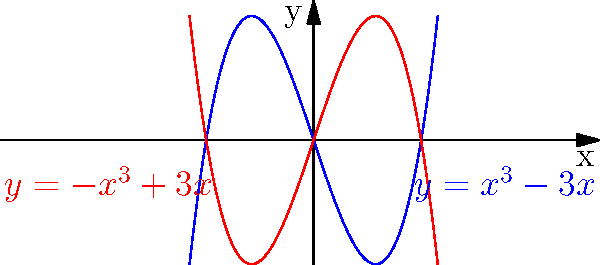As a creative mentor introducing new artistic techniques, you're demonstrating how polynomial functions can generate dynamic action lines in illustrations. The graph shows two cubic functions: $y=x^3-3x$ (blue) and $y=-x^3+3x$ (red). How could these curves be used to create a sense of movement in a graphic novel panel, and what specific artistic effect would they produce? To answer this question, let's analyze the curves and their potential applications in graphic novel illustrations:

1. Shape analysis:
   - Both curves are cubic functions, creating smooth, S-shaped lines.
   - They are symmetric about the origin, mirroring each other.

2. Dynamic properties:
   - The curves start with a gentle slope, then rapidly change direction.
   - This creates a sense of acceleration and deceleration.

3. Artistic applications:
   - These curves can represent motion trails or speed lines behind moving objects.
   - The blue curve could show an object moving from left to right, while the red curve shows movement from right to left.

4. Creating depth:
   - Using both curves together can create a sense of three-dimensionality.
   - This effect can make flat illustrations appear more dynamic and layered.

5. Emphasizing action:
   - The curves' inflection points (where they change direction) can highlight key moments in an action sequence.
   - This draws the reader's eye to important areas of the panel.

6. Stylistic variety:
   - By adjusting the polynomial coefficients, artists can create various curve shapes.
   - This allows for a range of expressive possibilities, from subtle motion to explosive action.

The artistic effect produced would be a sense of fluid, dynamic movement with varying speed and direction, adding energy and depth to the illustration.
Answer: The curves create fluid, dynamic motion trails with varying speed and direction, adding energy and depth to illustrations. 